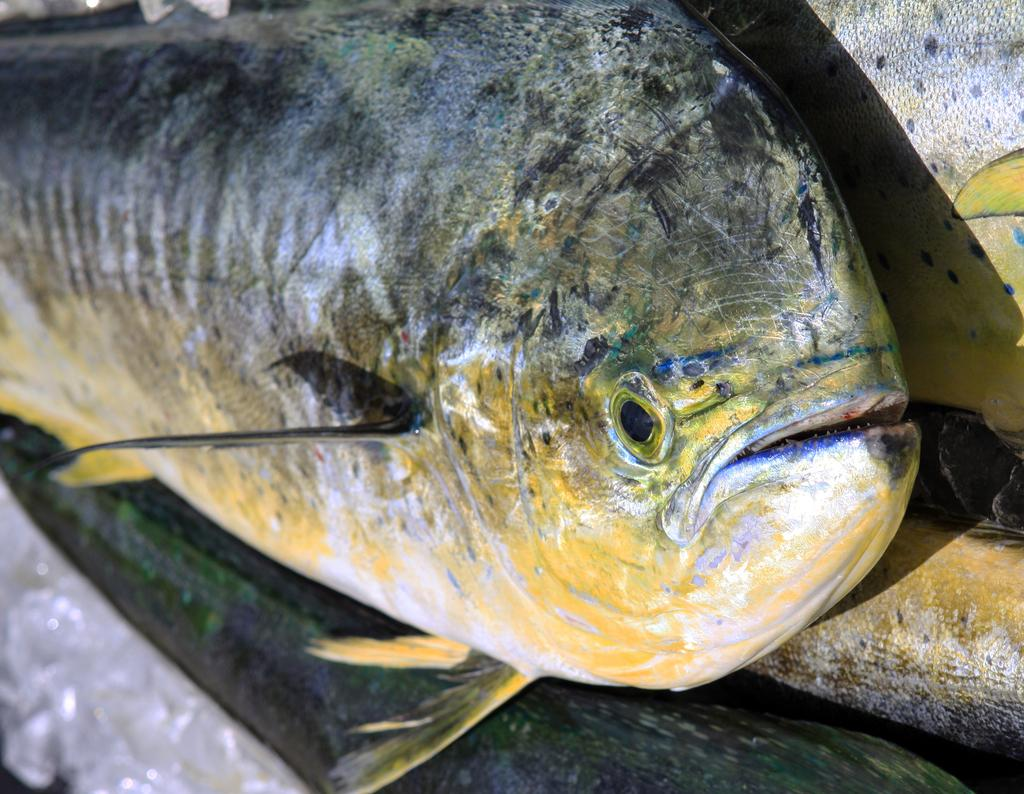What type of animals can be seen in the image? Fishes can be seen in the image. Where are the fishes located in the image? The fishes are likely in water, as they are aquatic animals. Can you describe the environment in which the fishes are situated? The environment is not specified in the image, but it is likely an aquatic setting. What type of yarn is being used to create the fishes in the image? There is no yarn present in the image, as the fishes are real animals and not crafted objects. 